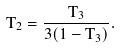<formula> <loc_0><loc_0><loc_500><loc_500>T _ { 2 } = \frac { T _ { 3 } } { 3 ( 1 - T _ { 3 } ) } .</formula> 